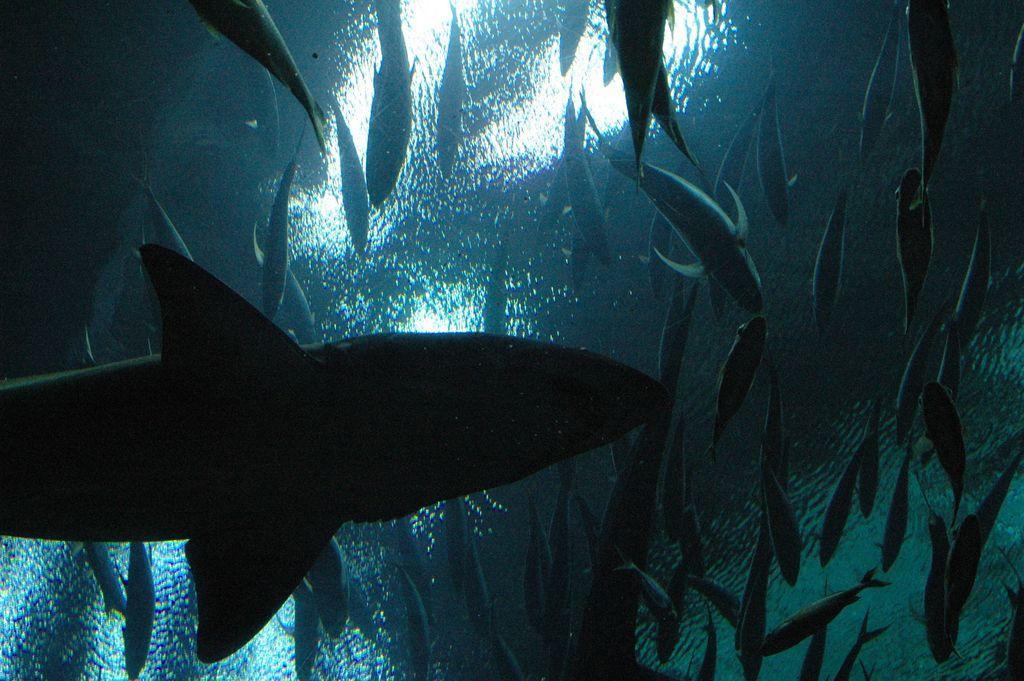Describe this image in one or two sentences. In this image I can see number of fish in the water. I can also see this image is inside view of the water. 